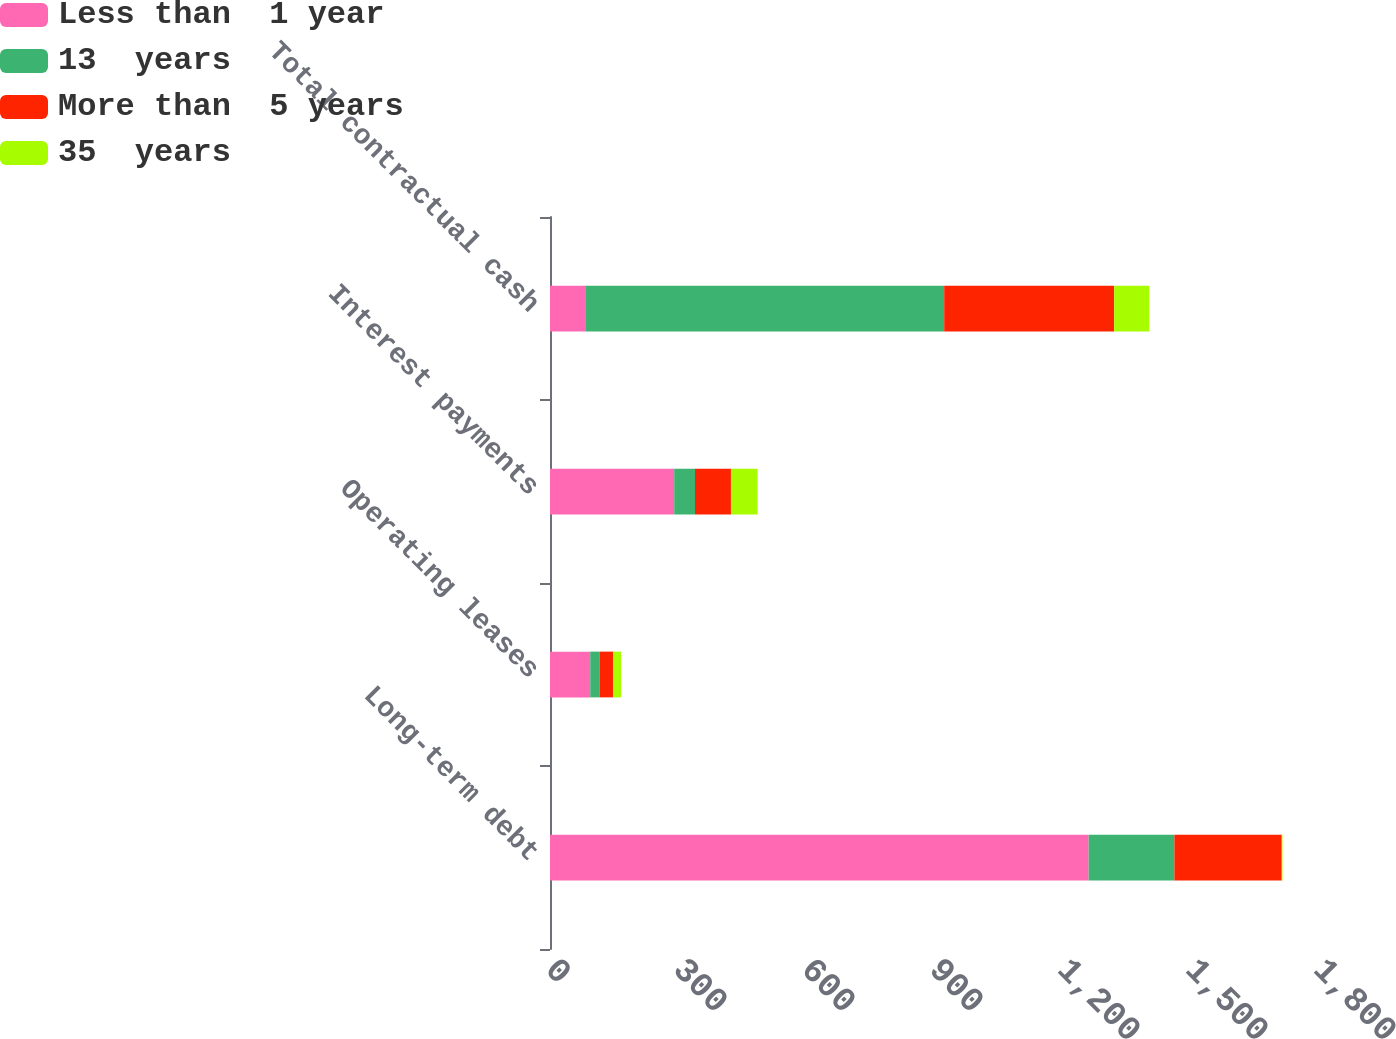Convert chart. <chart><loc_0><loc_0><loc_500><loc_500><stacked_bar_chart><ecel><fcel>Long-term debt<fcel>Operating leases<fcel>Interest payments<fcel>Total contractual cash<nl><fcel>Less than  1 year<fcel>1262.4<fcel>94.3<fcel>291.1<fcel>84.3<nl><fcel>13  years<fcel>201<fcel>22.5<fcel>48.7<fcel>839.6<nl><fcel>More than  5 years<fcel>251.7<fcel>31.6<fcel>84.3<fcel>398.3<nl><fcel>35  years<fcel>1.6<fcel>18.3<fcel>62.5<fcel>82.4<nl></chart> 